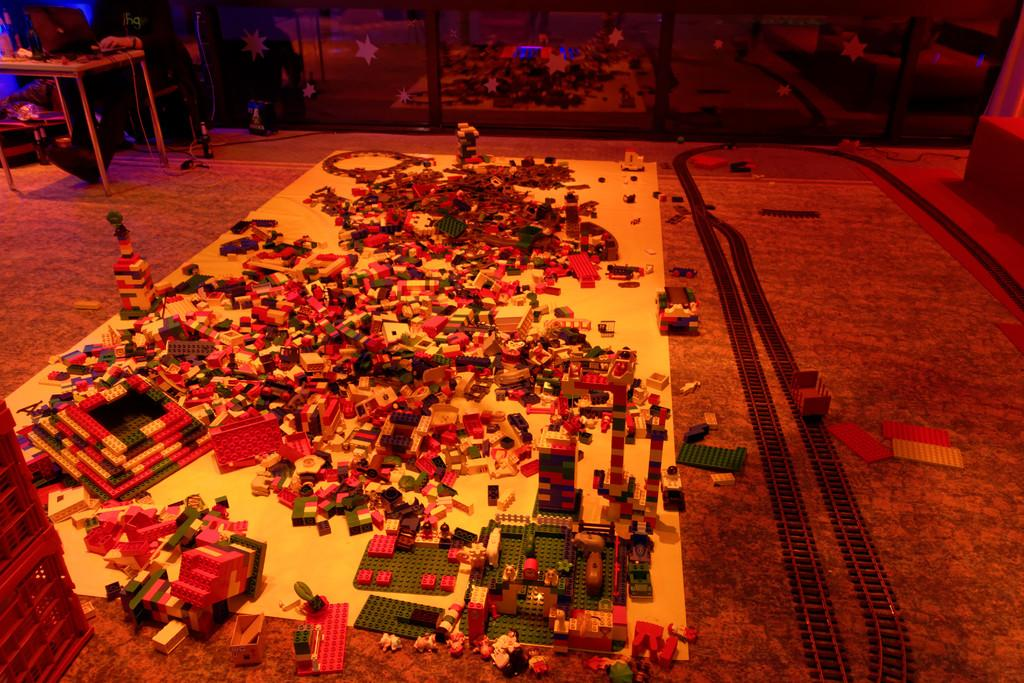What type of toys are on the floor in the image? There are lego toys on the floor. Can you describe the person's location in the image? The person is near a table in the image. What object can be seen in the background? There is a glass in the background. How does the zephyr affect the lego toys in the image? There is no mention of a zephyr in the image, so its effect on the lego toys cannot be determined. 